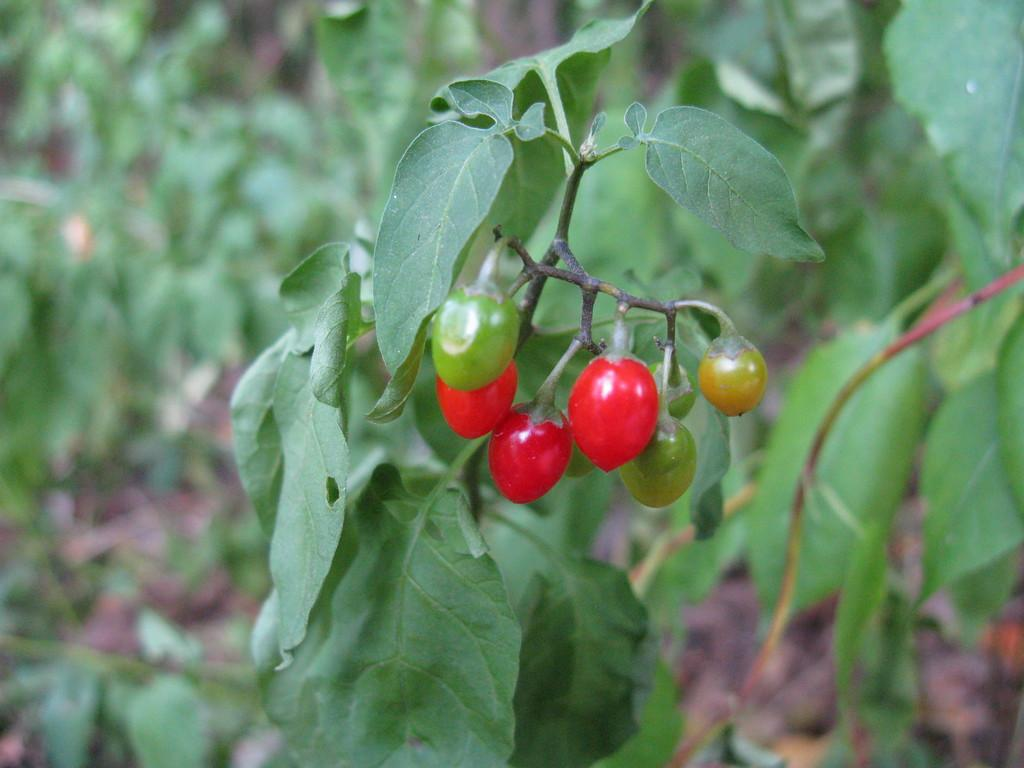What type of food can be seen in the image? There are vegetables in the image. What other living organisms are present in the image? There are plants in the image. How does the wealth of the rabbits in the image contribute to the growth of the plants? There are no rabbits present in the image, and therefore their wealth cannot contribute to the growth of the plants. 